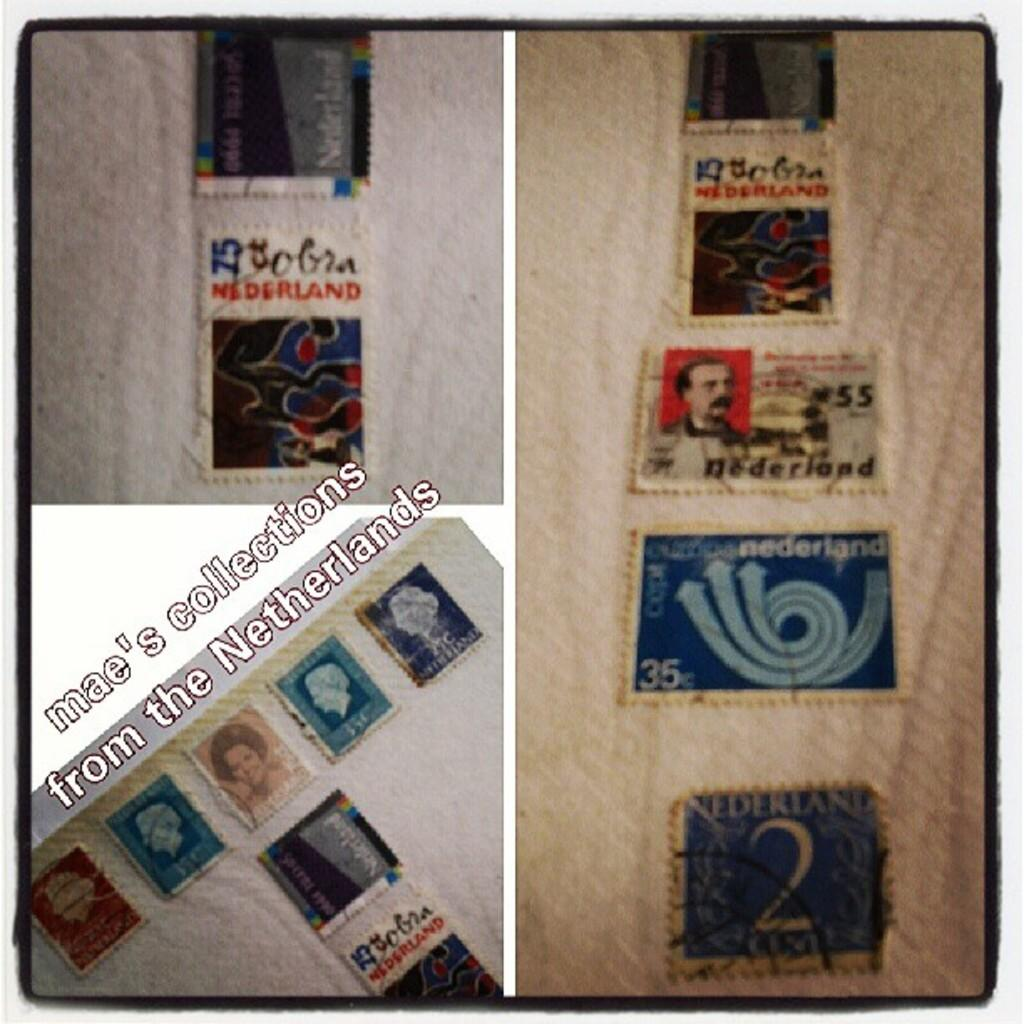How many pictures are included in the collage? The collage is made up of three pictures. What is the main subject of each picture in the collage? Each picture contains a collection of different stamps. What type of baseball equipment can be seen in the image? There is no baseball equipment present in the image; it is a collage of stamps. What color of paint is used on the stamps in the image? The image does not show the paint used on the stamps, as it is a collage of stamps and not a painting. 